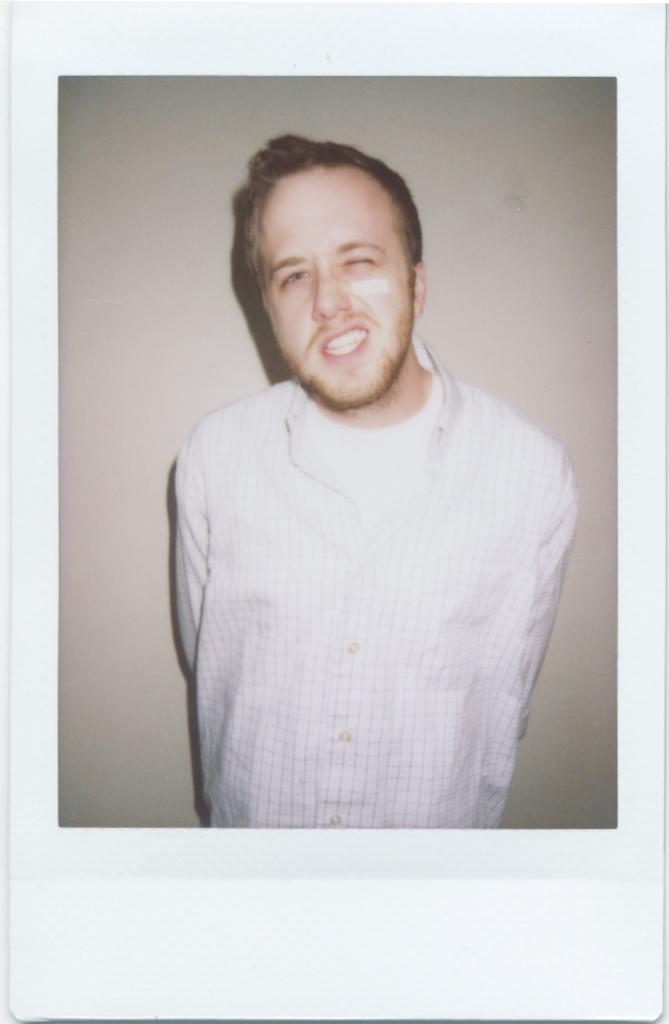What is the main subject of the image? There is a photo of a person in the image. What is the person in the photo doing? The person is standing. Can you describe the person's action in the photo? The person is blinking their eye. What type of fan is visible in the image? There is no fan present in the image; it features a photo of a person blinking their eye. What kind of competition is the person participating in within the image? There is no competition present in the image; it features a photo of a person blinking their eye. 